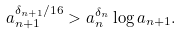Convert formula to latex. <formula><loc_0><loc_0><loc_500><loc_500>a _ { n + 1 } ^ { \delta _ { n + 1 } / 1 6 } > a _ { n } ^ { \delta _ { n } } \log a _ { n + 1 } .</formula> 